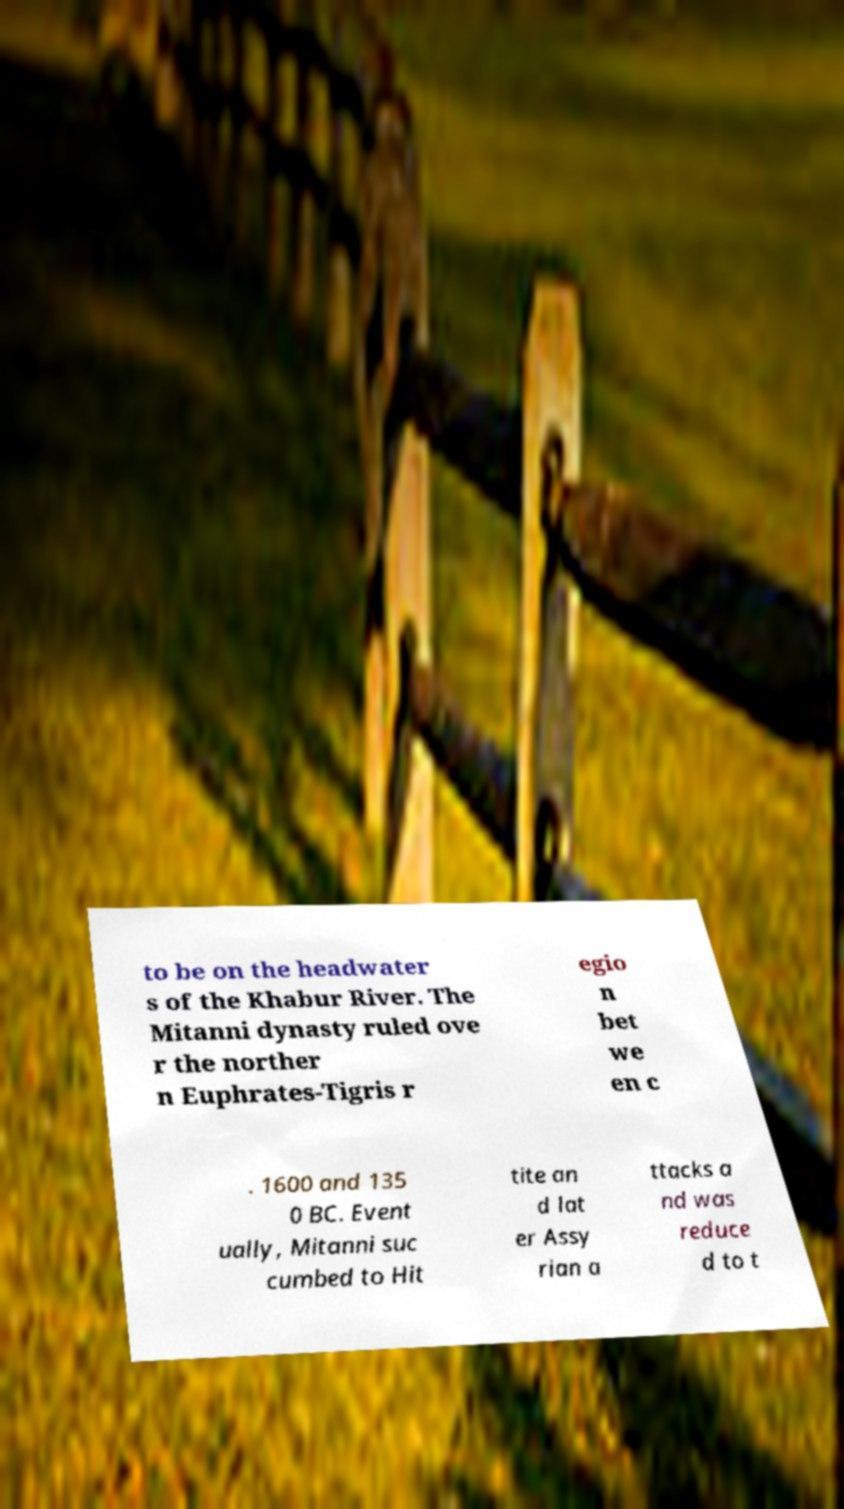Please identify and transcribe the text found in this image. to be on the headwater s of the Khabur River. The Mitanni dynasty ruled ove r the norther n Euphrates-Tigris r egio n bet we en c . 1600 and 135 0 BC. Event ually, Mitanni suc cumbed to Hit tite an d lat er Assy rian a ttacks a nd was reduce d to t 